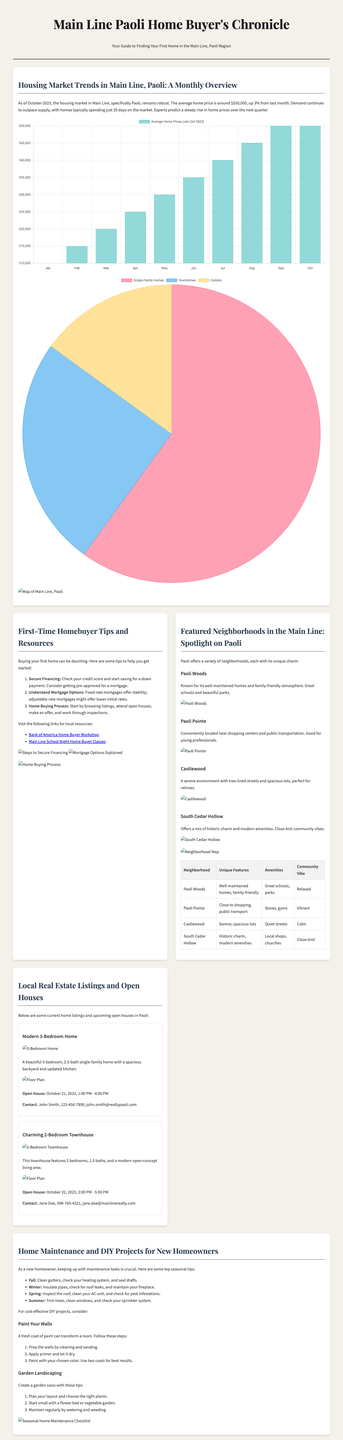what is the average home price in Paoli as of October 2023? The average home price in Paoli is mentioned as $550,000.
Answer: $550,000 how many days do homes typically spend on the market in Paoli? The document states that homes spend an average of 25 days on the market.
Answer: 25 days what percentage increase did the average home price see from last month? The article notes a 3% increase in average home price from last month.
Answer: 3% which neighborhood in Paoli is known for its family-friendly atmosphere? The document highlights Paoli Woods as family-friendly.
Answer: Paoli Woods what are the two open house dates listed in the document? The open house dates mentioned are October 21 and October 22, 2023.
Answer: October 21, October 22 what is a key tip for securing financing mentioned for first-time homebuyers? One key tip stated in the document is to check your credit score.
Answer: Check your credit score what is a DIY project suggested for new homeowners? Painting walls is suggested as a DIY project for new homeowners.
Answer: Paint Your Walls which real estate listing features a modern open-concept living area? The Charming 2-Bedroom Townhouse listing features a modern open-concept living area.
Answer: Charming 2-Bedroom Townhouse how many types of homes are mentioned in the market demand chart? The demand chart presents three different types of homes.
Answer: Three types 